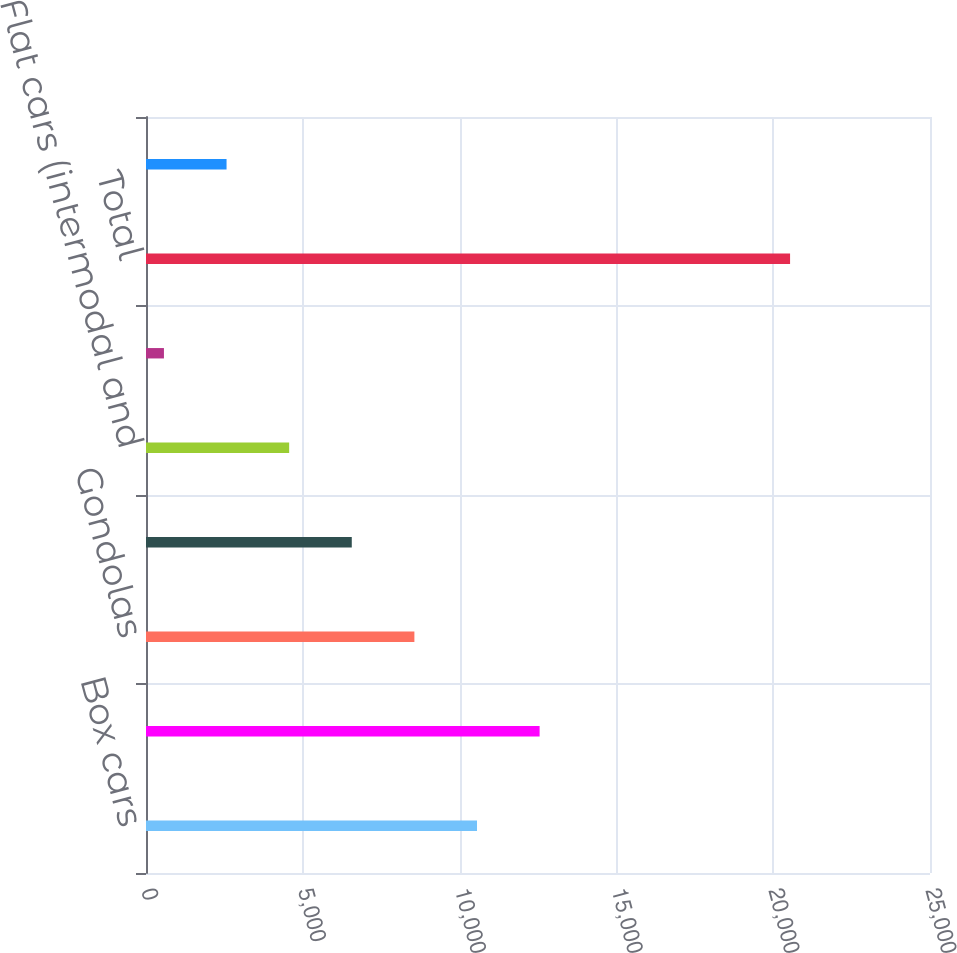<chart> <loc_0><loc_0><loc_500><loc_500><bar_chart><fcel>Box cars<fcel>Hoppers (covered and open top)<fcel>Gondolas<fcel>Automotive<fcel>Flat cars (intermodal and<fcel>Tank cars<fcel>Total<fcel>Freight<nl><fcel>10555<fcel>12551.6<fcel>8558.4<fcel>6561.8<fcel>4565.2<fcel>572<fcel>20538<fcel>2568.6<nl></chart> 